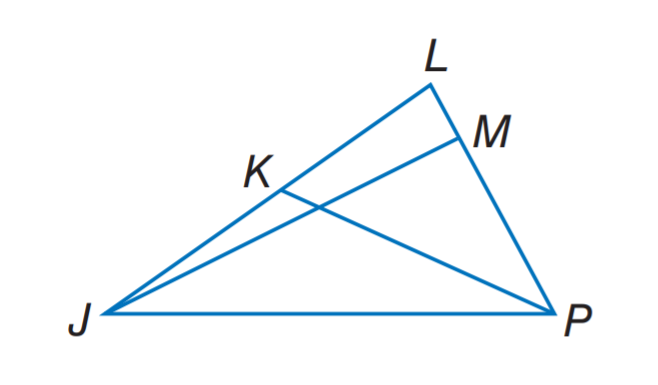Answer the mathemtical geometry problem and directly provide the correct option letter.
Question: In \triangle J L P, m \angle J M P = 3 x - 6, J K = 3 y - 2, and L K = 5 y - 8. If J M is an altitude of \triangle J L P, find x.
Choices: A: 23 B: 32 C: 35 D: 55 B 